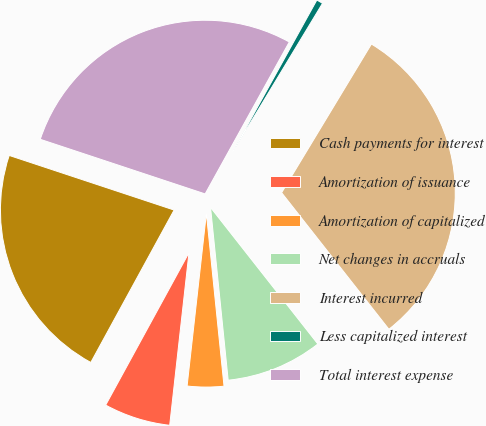Convert chart. <chart><loc_0><loc_0><loc_500><loc_500><pie_chart><fcel>Cash payments for interest<fcel>Amortization of issuance<fcel>Amortization of capitalized<fcel>Net changes in accruals<fcel>Interest incurred<fcel>Less capitalized interest<fcel>Total interest expense<nl><fcel>22.13%<fcel>6.19%<fcel>3.39%<fcel>8.98%<fcel>30.75%<fcel>0.6%<fcel>27.96%<nl></chart> 